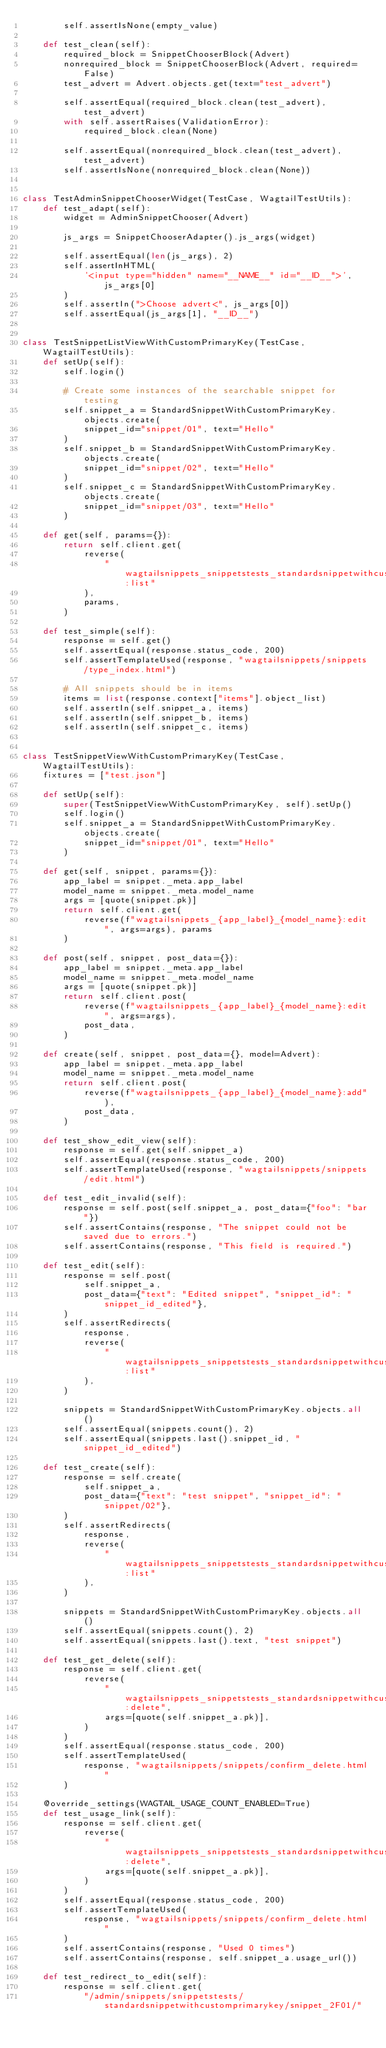<code> <loc_0><loc_0><loc_500><loc_500><_Python_>        self.assertIsNone(empty_value)

    def test_clean(self):
        required_block = SnippetChooserBlock(Advert)
        nonrequired_block = SnippetChooserBlock(Advert, required=False)
        test_advert = Advert.objects.get(text="test_advert")

        self.assertEqual(required_block.clean(test_advert), test_advert)
        with self.assertRaises(ValidationError):
            required_block.clean(None)

        self.assertEqual(nonrequired_block.clean(test_advert), test_advert)
        self.assertIsNone(nonrequired_block.clean(None))


class TestAdminSnippetChooserWidget(TestCase, WagtailTestUtils):
    def test_adapt(self):
        widget = AdminSnippetChooser(Advert)

        js_args = SnippetChooserAdapter().js_args(widget)

        self.assertEqual(len(js_args), 2)
        self.assertInHTML(
            '<input type="hidden" name="__NAME__" id="__ID__">', js_args[0]
        )
        self.assertIn(">Choose advert<", js_args[0])
        self.assertEqual(js_args[1], "__ID__")


class TestSnippetListViewWithCustomPrimaryKey(TestCase, WagtailTestUtils):
    def setUp(self):
        self.login()

        # Create some instances of the searchable snippet for testing
        self.snippet_a = StandardSnippetWithCustomPrimaryKey.objects.create(
            snippet_id="snippet/01", text="Hello"
        )
        self.snippet_b = StandardSnippetWithCustomPrimaryKey.objects.create(
            snippet_id="snippet/02", text="Hello"
        )
        self.snippet_c = StandardSnippetWithCustomPrimaryKey.objects.create(
            snippet_id="snippet/03", text="Hello"
        )

    def get(self, params={}):
        return self.client.get(
            reverse(
                "wagtailsnippets_snippetstests_standardsnippetwithcustomprimarykey:list"
            ),
            params,
        )

    def test_simple(self):
        response = self.get()
        self.assertEqual(response.status_code, 200)
        self.assertTemplateUsed(response, "wagtailsnippets/snippets/type_index.html")

        # All snippets should be in items
        items = list(response.context["items"].object_list)
        self.assertIn(self.snippet_a, items)
        self.assertIn(self.snippet_b, items)
        self.assertIn(self.snippet_c, items)


class TestSnippetViewWithCustomPrimaryKey(TestCase, WagtailTestUtils):
    fixtures = ["test.json"]

    def setUp(self):
        super(TestSnippetViewWithCustomPrimaryKey, self).setUp()
        self.login()
        self.snippet_a = StandardSnippetWithCustomPrimaryKey.objects.create(
            snippet_id="snippet/01", text="Hello"
        )

    def get(self, snippet, params={}):
        app_label = snippet._meta.app_label
        model_name = snippet._meta.model_name
        args = [quote(snippet.pk)]
        return self.client.get(
            reverse(f"wagtailsnippets_{app_label}_{model_name}:edit", args=args), params
        )

    def post(self, snippet, post_data={}):
        app_label = snippet._meta.app_label
        model_name = snippet._meta.model_name
        args = [quote(snippet.pk)]
        return self.client.post(
            reverse(f"wagtailsnippets_{app_label}_{model_name}:edit", args=args),
            post_data,
        )

    def create(self, snippet, post_data={}, model=Advert):
        app_label = snippet._meta.app_label
        model_name = snippet._meta.model_name
        return self.client.post(
            reverse(f"wagtailsnippets_{app_label}_{model_name}:add"),
            post_data,
        )

    def test_show_edit_view(self):
        response = self.get(self.snippet_a)
        self.assertEqual(response.status_code, 200)
        self.assertTemplateUsed(response, "wagtailsnippets/snippets/edit.html")

    def test_edit_invalid(self):
        response = self.post(self.snippet_a, post_data={"foo": "bar"})
        self.assertContains(response, "The snippet could not be saved due to errors.")
        self.assertContains(response, "This field is required.")

    def test_edit(self):
        response = self.post(
            self.snippet_a,
            post_data={"text": "Edited snippet", "snippet_id": "snippet_id_edited"},
        )
        self.assertRedirects(
            response,
            reverse(
                "wagtailsnippets_snippetstests_standardsnippetwithcustomprimarykey:list"
            ),
        )

        snippets = StandardSnippetWithCustomPrimaryKey.objects.all()
        self.assertEqual(snippets.count(), 2)
        self.assertEqual(snippets.last().snippet_id, "snippet_id_edited")

    def test_create(self):
        response = self.create(
            self.snippet_a,
            post_data={"text": "test snippet", "snippet_id": "snippet/02"},
        )
        self.assertRedirects(
            response,
            reverse(
                "wagtailsnippets_snippetstests_standardsnippetwithcustomprimarykey:list"
            ),
        )

        snippets = StandardSnippetWithCustomPrimaryKey.objects.all()
        self.assertEqual(snippets.count(), 2)
        self.assertEqual(snippets.last().text, "test snippet")

    def test_get_delete(self):
        response = self.client.get(
            reverse(
                "wagtailsnippets_snippetstests_standardsnippetwithcustomprimarykey:delete",
                args=[quote(self.snippet_a.pk)],
            )
        )
        self.assertEqual(response.status_code, 200)
        self.assertTemplateUsed(
            response, "wagtailsnippets/snippets/confirm_delete.html"
        )

    @override_settings(WAGTAIL_USAGE_COUNT_ENABLED=True)
    def test_usage_link(self):
        response = self.client.get(
            reverse(
                "wagtailsnippets_snippetstests_standardsnippetwithcustomprimarykey:delete",
                args=[quote(self.snippet_a.pk)],
            )
        )
        self.assertEqual(response.status_code, 200)
        self.assertTemplateUsed(
            response, "wagtailsnippets/snippets/confirm_delete.html"
        )
        self.assertContains(response, "Used 0 times")
        self.assertContains(response, self.snippet_a.usage_url())

    def test_redirect_to_edit(self):
        response = self.client.get(
            "/admin/snippets/snippetstests/standardsnippetwithcustomprimarykey/snippet_2F01/"</code> 